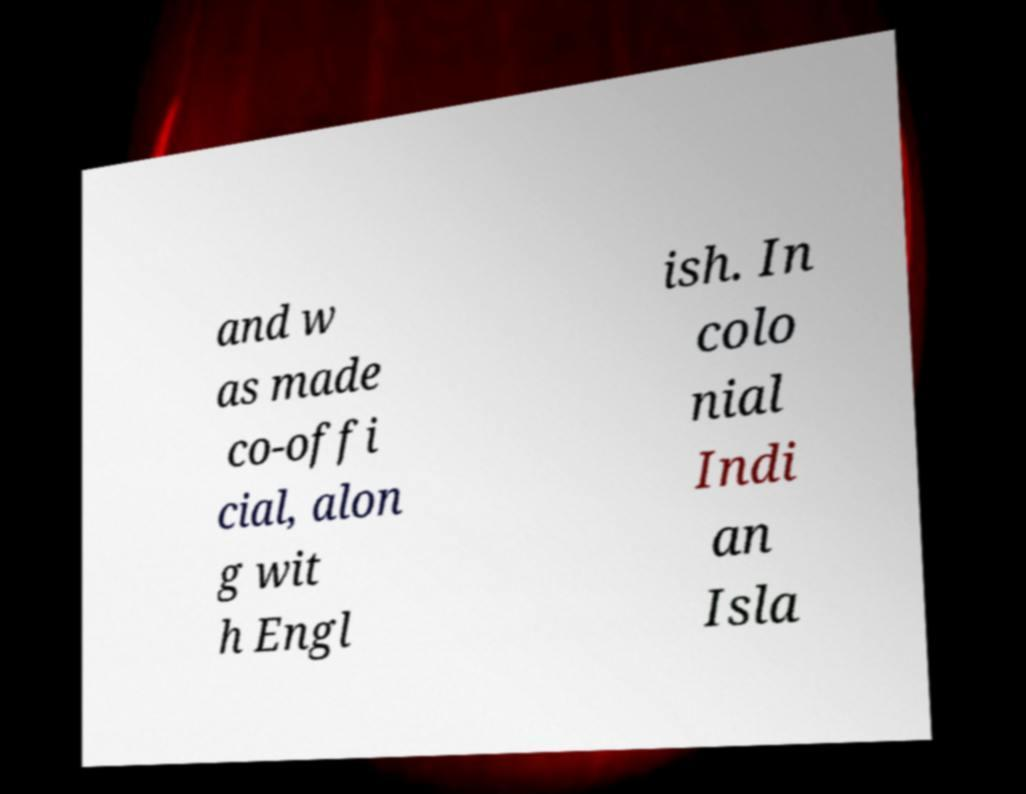What messages or text are displayed in this image? I need them in a readable, typed format. and w as made co-offi cial, alon g wit h Engl ish. In colo nial Indi an Isla 